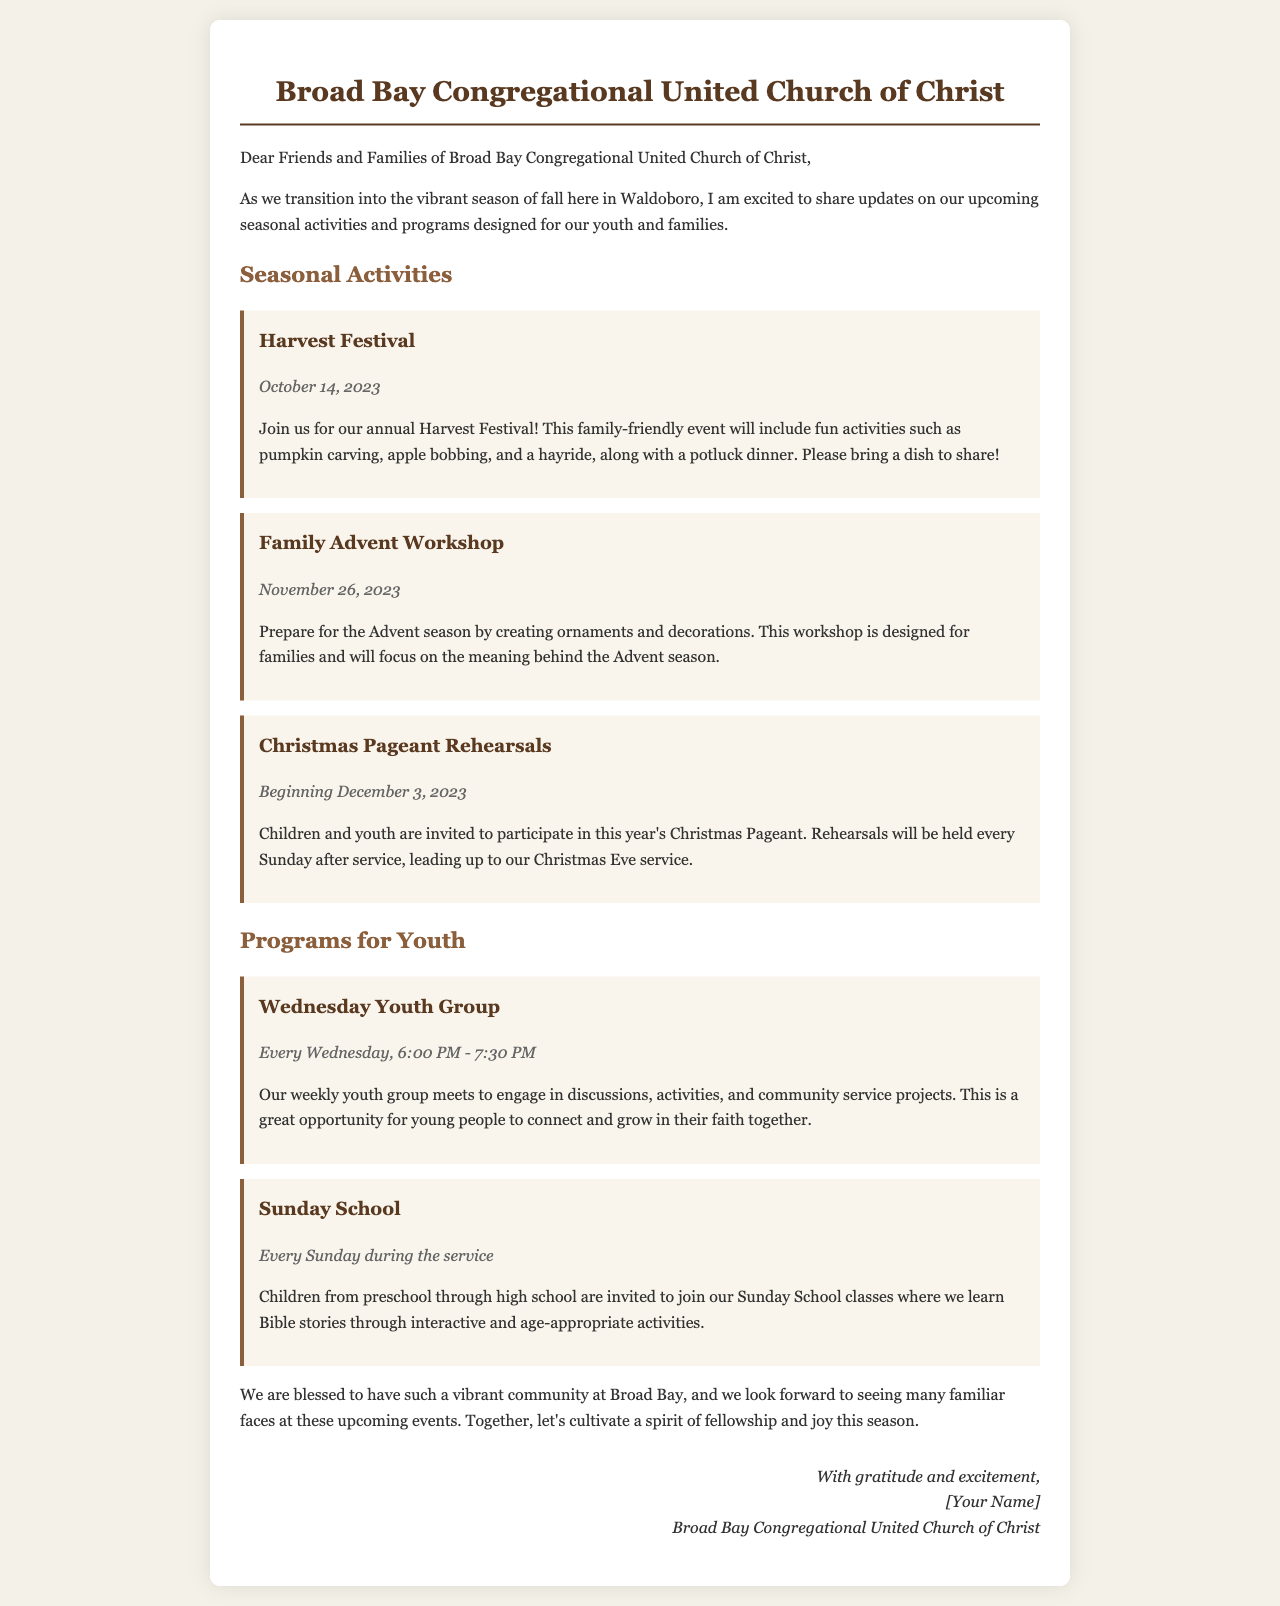What is the date of the Harvest Festival? The date for the Harvest Festival is explicitly mentioned in the document as October 14, 2023.
Answer: October 14, 2023 What activities are mentioned in the Harvest Festival? The document lists specific activities for the Harvest Festival, including pumpkin carving, apple bobbing, and a hayride.
Answer: Pumpkin carving, apple bobbing, hayride When does the Family Advent Workshop take place? The Family Advent Workshop date is clearly stated in the document as November 26, 2023.
Answer: November 26, 2023 What is the purpose of the Christmas Pageant Rehearsals? The document indicates that children and youth are invited to participate in rehearsals for the Christmas Pageant leading up to the Christmas Eve service.
Answer: To participate in the Christmas Pageant How often does the Wednesday Youth Group meet? The schedule for the Wednesday Youth Group is mentioned to be every Wednesday from 6:00 PM to 7:30 PM.
Answer: Every Wednesday What age groups are included in Sunday School? The document specifies that Sunday School is for children from preschool through high school.
Answer: Preschool through high school What type of dinner is planned for the Harvest Festival? The letter mentions a potluck dinner for the Harvest Festival.
Answer: Potluck dinner What is the focus of the Family Advent Workshop? The document states that the workshop will focus on creating ornaments and understanding the meaning behind the Advent season.
Answer: Creating ornaments and understanding Advent 